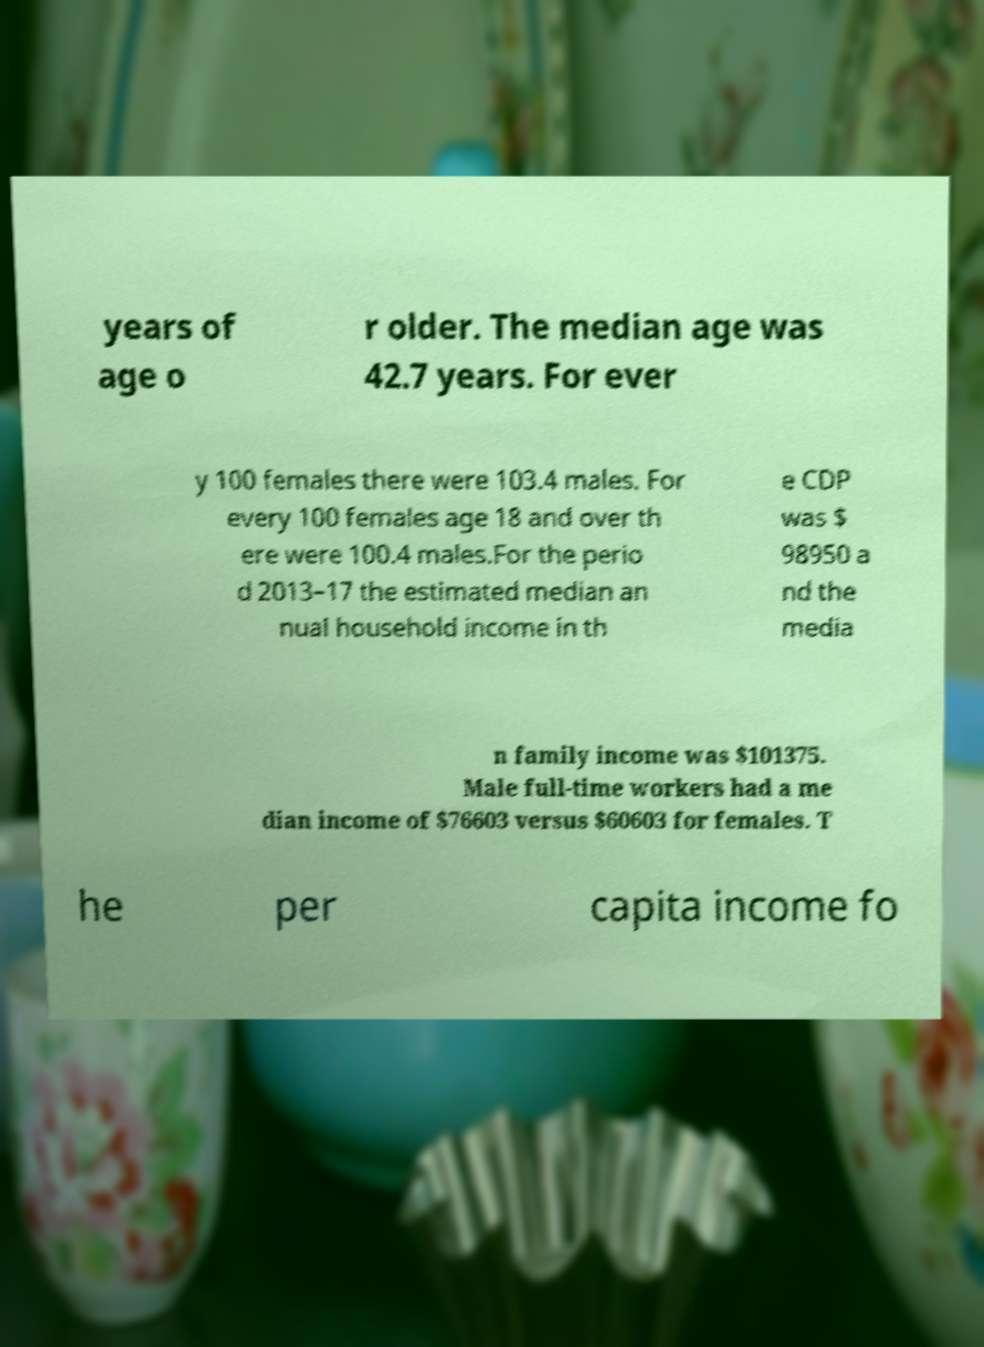Could you assist in decoding the text presented in this image and type it out clearly? years of age o r older. The median age was 42.7 years. For ever y 100 females there were 103.4 males. For every 100 females age 18 and over th ere were 100.4 males.For the perio d 2013–17 the estimated median an nual household income in th e CDP was $ 98950 a nd the media n family income was $101375. Male full-time workers had a me dian income of $76603 versus $60603 for females. T he per capita income fo 